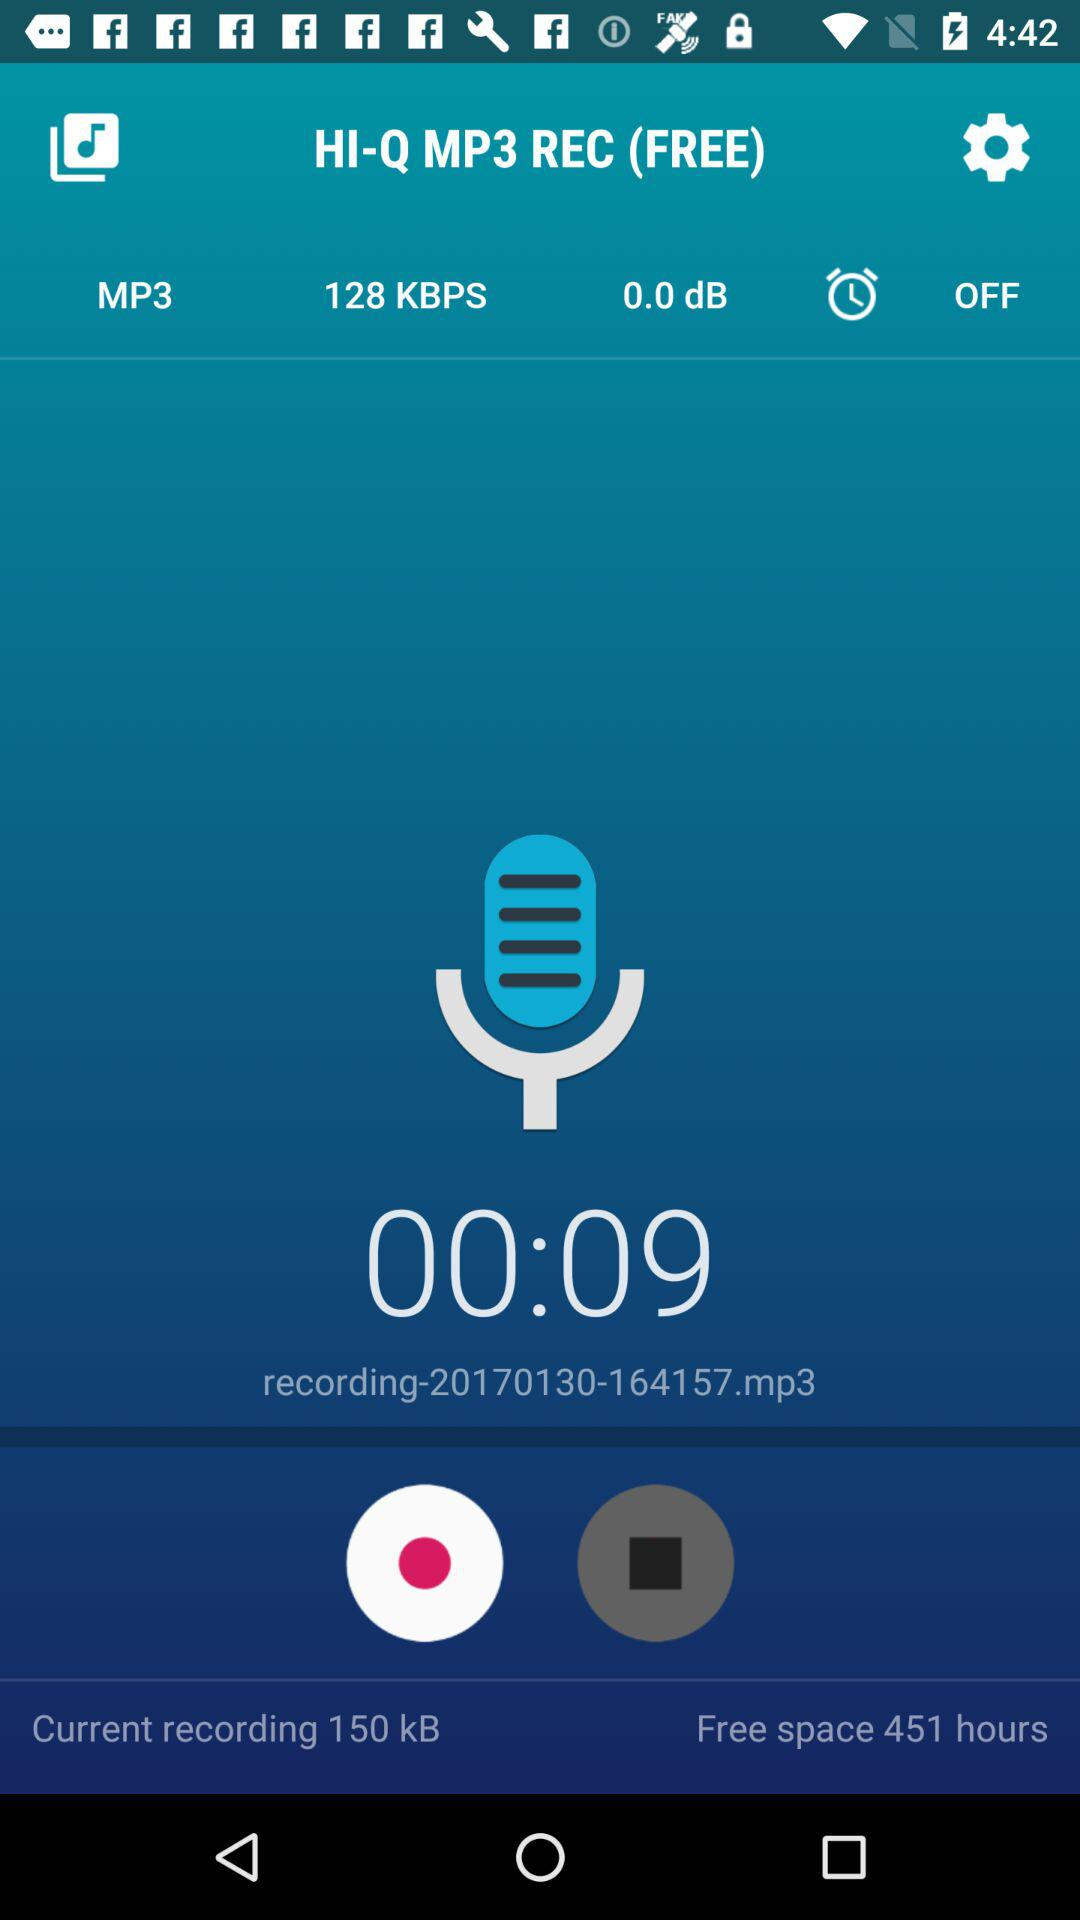How many hours of free space are there on the device?
Answer the question using a single word or phrase. 451 hours 